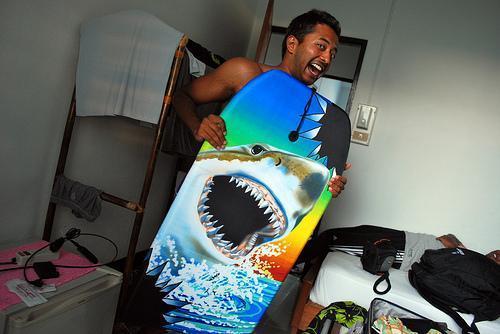How many people are there in this photo?
Give a very brief answer. 2. 